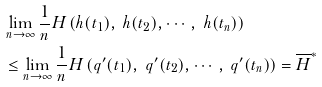Convert formula to latex. <formula><loc_0><loc_0><loc_500><loc_500>& \lim _ { n \rightarrow \infty } \frac { 1 } { n } H \left ( h ( t _ { 1 } ) , \ h ( t _ { 2 } ) , \cdots , \ h ( t _ { n } ) \right ) \\ & \leq \lim _ { n \rightarrow \infty } \frac { 1 } { n } H \left ( q ^ { \prime } ( t _ { 1 } ) , \ q ^ { \prime } ( t _ { 2 } ) , \cdots , \ q ^ { \prime } ( t _ { n } ) \right ) = \overline { H } ^ { * }</formula> 